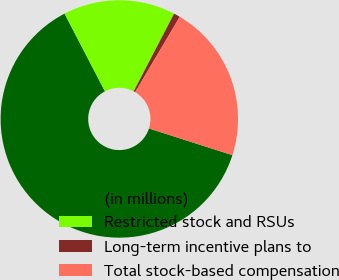Convert chart. <chart><loc_0><loc_0><loc_500><loc_500><pie_chart><fcel>(in millions)<fcel>Restricted stock and RSUs<fcel>Long-term incentive plans to<fcel>Total stock-based compensation<nl><fcel>62.44%<fcel>15.27%<fcel>0.87%<fcel>21.43%<nl></chart> 